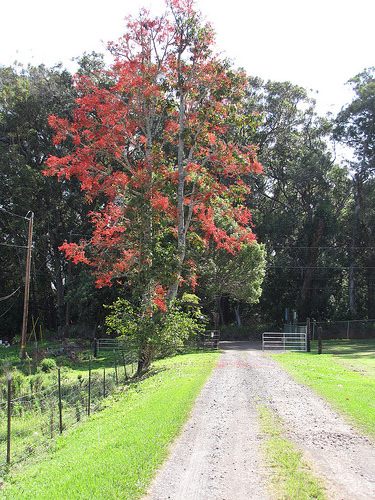<image>
Is the tree in front of the road? No. The tree is not in front of the road. The spatial positioning shows a different relationship between these objects. 